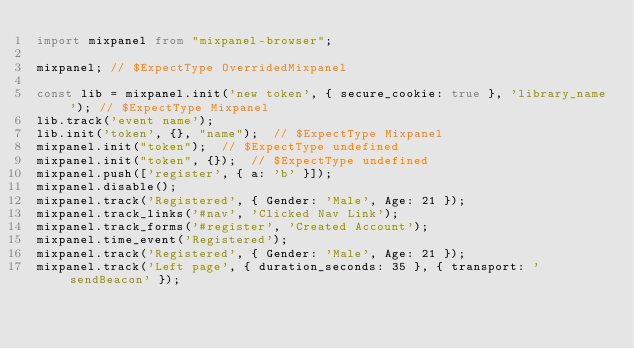<code> <loc_0><loc_0><loc_500><loc_500><_TypeScript_>import mixpanel from "mixpanel-browser";

mixpanel; // $ExpectType OverridedMixpanel

const lib = mixpanel.init('new token', { secure_cookie: true }, 'library_name'); // $ExpectType Mixpanel
lib.track('event name');
lib.init('token', {}, "name");  // $ExpectType Mixpanel
mixpanel.init("token");  // $ExpectType undefined
mixpanel.init("token", {});  // $ExpectType undefined
mixpanel.push(['register', { a: 'b' }]);
mixpanel.disable();
mixpanel.track('Registered', { Gender: 'Male', Age: 21 });
mixpanel.track_links('#nav', 'Clicked Nav Link');
mixpanel.track_forms('#register', 'Created Account');
mixpanel.time_event('Registered');
mixpanel.track('Registered', { Gender: 'Male', Age: 21 });
mixpanel.track('Left page', { duration_seconds: 35 }, { transport: 'sendBeacon' });</code> 